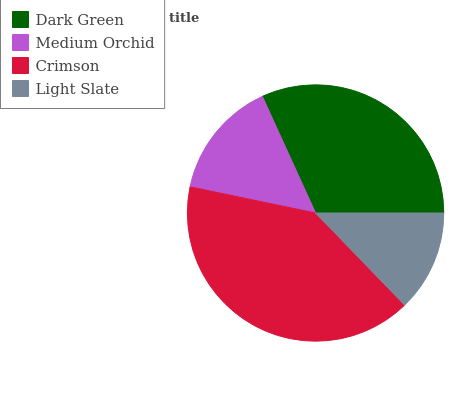Is Light Slate the minimum?
Answer yes or no. Yes. Is Crimson the maximum?
Answer yes or no. Yes. Is Medium Orchid the minimum?
Answer yes or no. No. Is Medium Orchid the maximum?
Answer yes or no. No. Is Dark Green greater than Medium Orchid?
Answer yes or no. Yes. Is Medium Orchid less than Dark Green?
Answer yes or no. Yes. Is Medium Orchid greater than Dark Green?
Answer yes or no. No. Is Dark Green less than Medium Orchid?
Answer yes or no. No. Is Dark Green the high median?
Answer yes or no. Yes. Is Medium Orchid the low median?
Answer yes or no. Yes. Is Crimson the high median?
Answer yes or no. No. Is Crimson the low median?
Answer yes or no. No. 